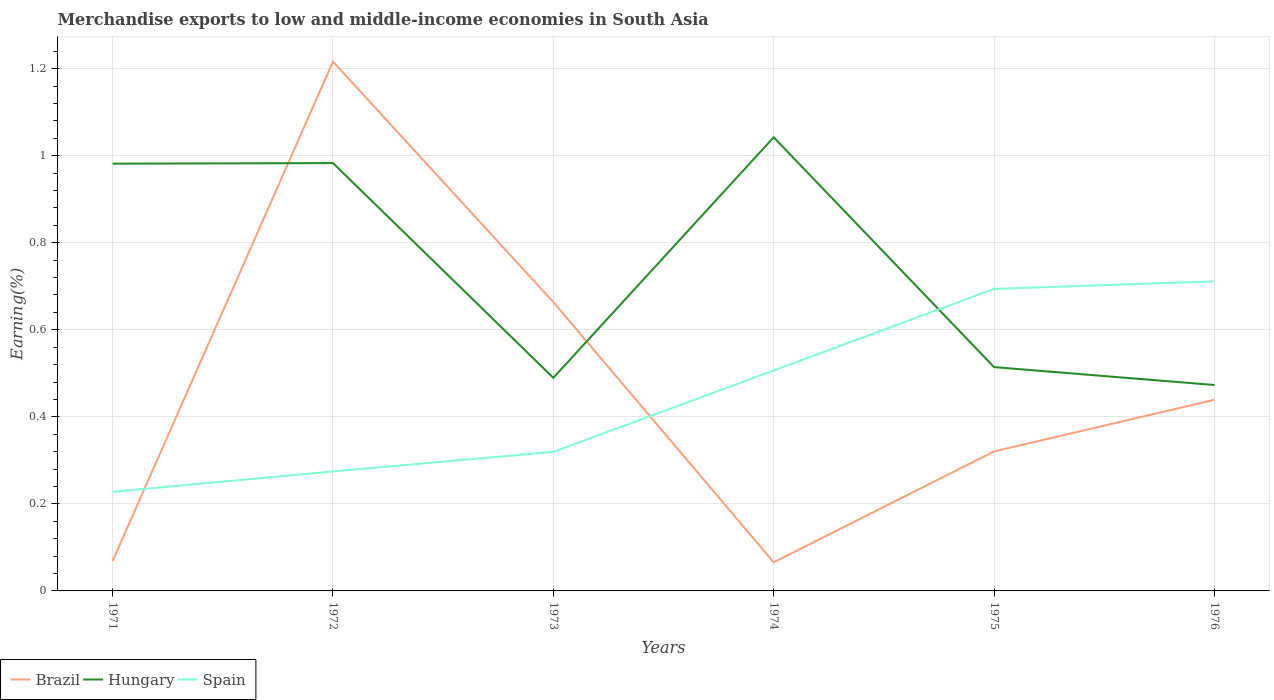Is the number of lines equal to the number of legend labels?
Give a very brief answer. Yes. Across all years, what is the maximum percentage of amount earned from merchandise exports in Brazil?
Provide a short and direct response. 0.07. What is the total percentage of amount earned from merchandise exports in Spain in the graph?
Keep it short and to the point. -0.19. What is the difference between the highest and the second highest percentage of amount earned from merchandise exports in Brazil?
Provide a succinct answer. 1.15. What is the difference between the highest and the lowest percentage of amount earned from merchandise exports in Spain?
Offer a terse response. 3. How many lines are there?
Give a very brief answer. 3. Does the graph contain grids?
Provide a succinct answer. Yes. How are the legend labels stacked?
Give a very brief answer. Horizontal. What is the title of the graph?
Provide a succinct answer. Merchandise exports to low and middle-income economies in South Asia. What is the label or title of the Y-axis?
Offer a terse response. Earning(%). What is the Earning(%) in Brazil in 1971?
Provide a succinct answer. 0.07. What is the Earning(%) in Hungary in 1971?
Give a very brief answer. 0.98. What is the Earning(%) of Spain in 1971?
Offer a terse response. 0.23. What is the Earning(%) of Brazil in 1972?
Offer a very short reply. 1.22. What is the Earning(%) of Hungary in 1972?
Make the answer very short. 0.98. What is the Earning(%) of Spain in 1972?
Make the answer very short. 0.27. What is the Earning(%) of Brazil in 1973?
Your response must be concise. 0.66. What is the Earning(%) of Hungary in 1973?
Your answer should be very brief. 0.49. What is the Earning(%) in Spain in 1973?
Offer a very short reply. 0.32. What is the Earning(%) in Brazil in 1974?
Provide a short and direct response. 0.07. What is the Earning(%) of Hungary in 1974?
Your answer should be compact. 1.04. What is the Earning(%) in Spain in 1974?
Provide a succinct answer. 0.51. What is the Earning(%) in Brazil in 1975?
Offer a very short reply. 0.32. What is the Earning(%) of Hungary in 1975?
Give a very brief answer. 0.51. What is the Earning(%) of Spain in 1975?
Give a very brief answer. 0.69. What is the Earning(%) in Brazil in 1976?
Your answer should be very brief. 0.44. What is the Earning(%) in Hungary in 1976?
Your answer should be compact. 0.47. What is the Earning(%) in Spain in 1976?
Offer a very short reply. 0.71. Across all years, what is the maximum Earning(%) in Brazil?
Make the answer very short. 1.22. Across all years, what is the maximum Earning(%) of Hungary?
Give a very brief answer. 1.04. Across all years, what is the maximum Earning(%) of Spain?
Your response must be concise. 0.71. Across all years, what is the minimum Earning(%) in Brazil?
Your answer should be compact. 0.07. Across all years, what is the minimum Earning(%) of Hungary?
Provide a short and direct response. 0.47. Across all years, what is the minimum Earning(%) in Spain?
Ensure brevity in your answer.  0.23. What is the total Earning(%) in Brazil in the graph?
Make the answer very short. 2.77. What is the total Earning(%) of Hungary in the graph?
Provide a succinct answer. 4.48. What is the total Earning(%) of Spain in the graph?
Offer a very short reply. 2.73. What is the difference between the Earning(%) in Brazil in 1971 and that in 1972?
Provide a short and direct response. -1.15. What is the difference between the Earning(%) in Hungary in 1971 and that in 1972?
Offer a terse response. -0. What is the difference between the Earning(%) of Spain in 1971 and that in 1972?
Your response must be concise. -0.05. What is the difference between the Earning(%) in Brazil in 1971 and that in 1973?
Your response must be concise. -0.59. What is the difference between the Earning(%) of Hungary in 1971 and that in 1973?
Your response must be concise. 0.49. What is the difference between the Earning(%) in Spain in 1971 and that in 1973?
Keep it short and to the point. -0.09. What is the difference between the Earning(%) in Brazil in 1971 and that in 1974?
Ensure brevity in your answer.  0. What is the difference between the Earning(%) of Hungary in 1971 and that in 1974?
Provide a short and direct response. -0.06. What is the difference between the Earning(%) in Spain in 1971 and that in 1974?
Offer a terse response. -0.28. What is the difference between the Earning(%) of Brazil in 1971 and that in 1975?
Your answer should be compact. -0.25. What is the difference between the Earning(%) in Hungary in 1971 and that in 1975?
Make the answer very short. 0.47. What is the difference between the Earning(%) of Spain in 1971 and that in 1975?
Offer a terse response. -0.47. What is the difference between the Earning(%) of Brazil in 1971 and that in 1976?
Your response must be concise. -0.37. What is the difference between the Earning(%) in Hungary in 1971 and that in 1976?
Make the answer very short. 0.51. What is the difference between the Earning(%) of Spain in 1971 and that in 1976?
Offer a very short reply. -0.48. What is the difference between the Earning(%) in Brazil in 1972 and that in 1973?
Provide a succinct answer. 0.55. What is the difference between the Earning(%) of Hungary in 1972 and that in 1973?
Give a very brief answer. 0.49. What is the difference between the Earning(%) of Spain in 1972 and that in 1973?
Your answer should be very brief. -0.04. What is the difference between the Earning(%) in Brazil in 1972 and that in 1974?
Provide a succinct answer. 1.15. What is the difference between the Earning(%) in Hungary in 1972 and that in 1974?
Offer a terse response. -0.06. What is the difference between the Earning(%) in Spain in 1972 and that in 1974?
Offer a terse response. -0.23. What is the difference between the Earning(%) of Brazil in 1972 and that in 1975?
Offer a terse response. 0.9. What is the difference between the Earning(%) in Hungary in 1972 and that in 1975?
Make the answer very short. 0.47. What is the difference between the Earning(%) in Spain in 1972 and that in 1975?
Provide a succinct answer. -0.42. What is the difference between the Earning(%) of Brazil in 1972 and that in 1976?
Offer a very short reply. 0.78. What is the difference between the Earning(%) of Hungary in 1972 and that in 1976?
Your response must be concise. 0.51. What is the difference between the Earning(%) of Spain in 1972 and that in 1976?
Offer a very short reply. -0.44. What is the difference between the Earning(%) of Brazil in 1973 and that in 1974?
Offer a terse response. 0.6. What is the difference between the Earning(%) of Hungary in 1973 and that in 1974?
Ensure brevity in your answer.  -0.55. What is the difference between the Earning(%) of Spain in 1973 and that in 1974?
Offer a terse response. -0.19. What is the difference between the Earning(%) in Brazil in 1973 and that in 1975?
Your answer should be very brief. 0.34. What is the difference between the Earning(%) in Hungary in 1973 and that in 1975?
Provide a succinct answer. -0.02. What is the difference between the Earning(%) of Spain in 1973 and that in 1975?
Keep it short and to the point. -0.37. What is the difference between the Earning(%) of Brazil in 1973 and that in 1976?
Your answer should be compact. 0.22. What is the difference between the Earning(%) of Hungary in 1973 and that in 1976?
Ensure brevity in your answer.  0.02. What is the difference between the Earning(%) of Spain in 1973 and that in 1976?
Your answer should be compact. -0.39. What is the difference between the Earning(%) in Brazil in 1974 and that in 1975?
Your answer should be compact. -0.25. What is the difference between the Earning(%) of Hungary in 1974 and that in 1975?
Keep it short and to the point. 0.53. What is the difference between the Earning(%) in Spain in 1974 and that in 1975?
Your response must be concise. -0.19. What is the difference between the Earning(%) in Brazil in 1974 and that in 1976?
Provide a succinct answer. -0.37. What is the difference between the Earning(%) in Hungary in 1974 and that in 1976?
Keep it short and to the point. 0.57. What is the difference between the Earning(%) of Spain in 1974 and that in 1976?
Your answer should be compact. -0.2. What is the difference between the Earning(%) of Brazil in 1975 and that in 1976?
Your answer should be very brief. -0.12. What is the difference between the Earning(%) of Hungary in 1975 and that in 1976?
Offer a terse response. 0.04. What is the difference between the Earning(%) of Spain in 1975 and that in 1976?
Give a very brief answer. -0.02. What is the difference between the Earning(%) in Brazil in 1971 and the Earning(%) in Hungary in 1972?
Your answer should be compact. -0.91. What is the difference between the Earning(%) in Brazil in 1971 and the Earning(%) in Spain in 1972?
Give a very brief answer. -0.21. What is the difference between the Earning(%) in Hungary in 1971 and the Earning(%) in Spain in 1972?
Make the answer very short. 0.71. What is the difference between the Earning(%) of Brazil in 1971 and the Earning(%) of Hungary in 1973?
Give a very brief answer. -0.42. What is the difference between the Earning(%) of Brazil in 1971 and the Earning(%) of Spain in 1973?
Give a very brief answer. -0.25. What is the difference between the Earning(%) in Hungary in 1971 and the Earning(%) in Spain in 1973?
Provide a succinct answer. 0.66. What is the difference between the Earning(%) in Brazil in 1971 and the Earning(%) in Hungary in 1974?
Offer a terse response. -0.97. What is the difference between the Earning(%) in Brazil in 1971 and the Earning(%) in Spain in 1974?
Your answer should be compact. -0.44. What is the difference between the Earning(%) in Hungary in 1971 and the Earning(%) in Spain in 1974?
Provide a short and direct response. 0.48. What is the difference between the Earning(%) of Brazil in 1971 and the Earning(%) of Hungary in 1975?
Keep it short and to the point. -0.45. What is the difference between the Earning(%) in Brazil in 1971 and the Earning(%) in Spain in 1975?
Make the answer very short. -0.63. What is the difference between the Earning(%) in Hungary in 1971 and the Earning(%) in Spain in 1975?
Your answer should be compact. 0.29. What is the difference between the Earning(%) of Brazil in 1971 and the Earning(%) of Hungary in 1976?
Ensure brevity in your answer.  -0.4. What is the difference between the Earning(%) in Brazil in 1971 and the Earning(%) in Spain in 1976?
Give a very brief answer. -0.64. What is the difference between the Earning(%) in Hungary in 1971 and the Earning(%) in Spain in 1976?
Ensure brevity in your answer.  0.27. What is the difference between the Earning(%) of Brazil in 1972 and the Earning(%) of Hungary in 1973?
Offer a terse response. 0.73. What is the difference between the Earning(%) of Brazil in 1972 and the Earning(%) of Spain in 1973?
Provide a succinct answer. 0.9. What is the difference between the Earning(%) of Hungary in 1972 and the Earning(%) of Spain in 1973?
Offer a very short reply. 0.66. What is the difference between the Earning(%) in Brazil in 1972 and the Earning(%) in Hungary in 1974?
Your answer should be very brief. 0.17. What is the difference between the Earning(%) in Brazil in 1972 and the Earning(%) in Spain in 1974?
Keep it short and to the point. 0.71. What is the difference between the Earning(%) in Hungary in 1972 and the Earning(%) in Spain in 1974?
Give a very brief answer. 0.48. What is the difference between the Earning(%) in Brazil in 1972 and the Earning(%) in Hungary in 1975?
Your response must be concise. 0.7. What is the difference between the Earning(%) in Brazil in 1972 and the Earning(%) in Spain in 1975?
Your answer should be very brief. 0.52. What is the difference between the Earning(%) in Hungary in 1972 and the Earning(%) in Spain in 1975?
Offer a very short reply. 0.29. What is the difference between the Earning(%) of Brazil in 1972 and the Earning(%) of Hungary in 1976?
Provide a short and direct response. 0.74. What is the difference between the Earning(%) in Brazil in 1972 and the Earning(%) in Spain in 1976?
Offer a very short reply. 0.51. What is the difference between the Earning(%) of Hungary in 1972 and the Earning(%) of Spain in 1976?
Ensure brevity in your answer.  0.27. What is the difference between the Earning(%) in Brazil in 1973 and the Earning(%) in Hungary in 1974?
Give a very brief answer. -0.38. What is the difference between the Earning(%) of Brazil in 1973 and the Earning(%) of Spain in 1974?
Your answer should be very brief. 0.16. What is the difference between the Earning(%) of Hungary in 1973 and the Earning(%) of Spain in 1974?
Your response must be concise. -0.02. What is the difference between the Earning(%) of Brazil in 1973 and the Earning(%) of Hungary in 1975?
Your response must be concise. 0.15. What is the difference between the Earning(%) of Brazil in 1973 and the Earning(%) of Spain in 1975?
Provide a succinct answer. -0.03. What is the difference between the Earning(%) of Hungary in 1973 and the Earning(%) of Spain in 1975?
Give a very brief answer. -0.2. What is the difference between the Earning(%) of Brazil in 1973 and the Earning(%) of Hungary in 1976?
Keep it short and to the point. 0.19. What is the difference between the Earning(%) in Brazil in 1973 and the Earning(%) in Spain in 1976?
Offer a terse response. -0.05. What is the difference between the Earning(%) in Hungary in 1973 and the Earning(%) in Spain in 1976?
Offer a terse response. -0.22. What is the difference between the Earning(%) in Brazil in 1974 and the Earning(%) in Hungary in 1975?
Make the answer very short. -0.45. What is the difference between the Earning(%) in Brazil in 1974 and the Earning(%) in Spain in 1975?
Your answer should be compact. -0.63. What is the difference between the Earning(%) in Hungary in 1974 and the Earning(%) in Spain in 1975?
Your answer should be compact. 0.35. What is the difference between the Earning(%) in Brazil in 1974 and the Earning(%) in Hungary in 1976?
Offer a terse response. -0.41. What is the difference between the Earning(%) in Brazil in 1974 and the Earning(%) in Spain in 1976?
Offer a terse response. -0.65. What is the difference between the Earning(%) in Hungary in 1974 and the Earning(%) in Spain in 1976?
Ensure brevity in your answer.  0.33. What is the difference between the Earning(%) in Brazil in 1975 and the Earning(%) in Hungary in 1976?
Ensure brevity in your answer.  -0.15. What is the difference between the Earning(%) of Brazil in 1975 and the Earning(%) of Spain in 1976?
Keep it short and to the point. -0.39. What is the difference between the Earning(%) in Hungary in 1975 and the Earning(%) in Spain in 1976?
Ensure brevity in your answer.  -0.2. What is the average Earning(%) of Brazil per year?
Give a very brief answer. 0.46. What is the average Earning(%) in Hungary per year?
Make the answer very short. 0.75. What is the average Earning(%) in Spain per year?
Offer a very short reply. 0.46. In the year 1971, what is the difference between the Earning(%) of Brazil and Earning(%) of Hungary?
Make the answer very short. -0.91. In the year 1971, what is the difference between the Earning(%) of Brazil and Earning(%) of Spain?
Ensure brevity in your answer.  -0.16. In the year 1971, what is the difference between the Earning(%) of Hungary and Earning(%) of Spain?
Your response must be concise. 0.75. In the year 1972, what is the difference between the Earning(%) of Brazil and Earning(%) of Hungary?
Offer a very short reply. 0.23. In the year 1972, what is the difference between the Earning(%) of Brazil and Earning(%) of Spain?
Keep it short and to the point. 0.94. In the year 1972, what is the difference between the Earning(%) in Hungary and Earning(%) in Spain?
Give a very brief answer. 0.71. In the year 1973, what is the difference between the Earning(%) in Brazil and Earning(%) in Hungary?
Ensure brevity in your answer.  0.17. In the year 1973, what is the difference between the Earning(%) in Brazil and Earning(%) in Spain?
Ensure brevity in your answer.  0.34. In the year 1973, what is the difference between the Earning(%) in Hungary and Earning(%) in Spain?
Your answer should be compact. 0.17. In the year 1974, what is the difference between the Earning(%) of Brazil and Earning(%) of Hungary?
Offer a terse response. -0.98. In the year 1974, what is the difference between the Earning(%) of Brazil and Earning(%) of Spain?
Provide a short and direct response. -0.44. In the year 1974, what is the difference between the Earning(%) of Hungary and Earning(%) of Spain?
Your answer should be compact. 0.54. In the year 1975, what is the difference between the Earning(%) of Brazil and Earning(%) of Hungary?
Make the answer very short. -0.19. In the year 1975, what is the difference between the Earning(%) of Brazil and Earning(%) of Spain?
Provide a succinct answer. -0.37. In the year 1975, what is the difference between the Earning(%) of Hungary and Earning(%) of Spain?
Your answer should be very brief. -0.18. In the year 1976, what is the difference between the Earning(%) in Brazil and Earning(%) in Hungary?
Offer a terse response. -0.03. In the year 1976, what is the difference between the Earning(%) of Brazil and Earning(%) of Spain?
Make the answer very short. -0.27. In the year 1976, what is the difference between the Earning(%) in Hungary and Earning(%) in Spain?
Offer a terse response. -0.24. What is the ratio of the Earning(%) of Brazil in 1971 to that in 1972?
Your response must be concise. 0.06. What is the ratio of the Earning(%) in Spain in 1971 to that in 1972?
Your answer should be compact. 0.83. What is the ratio of the Earning(%) of Brazil in 1971 to that in 1973?
Provide a succinct answer. 0.1. What is the ratio of the Earning(%) in Hungary in 1971 to that in 1973?
Your response must be concise. 2. What is the ratio of the Earning(%) in Spain in 1971 to that in 1973?
Provide a short and direct response. 0.71. What is the ratio of the Earning(%) in Brazil in 1971 to that in 1974?
Offer a very short reply. 1.05. What is the ratio of the Earning(%) of Hungary in 1971 to that in 1974?
Make the answer very short. 0.94. What is the ratio of the Earning(%) in Spain in 1971 to that in 1974?
Give a very brief answer. 0.45. What is the ratio of the Earning(%) of Brazil in 1971 to that in 1975?
Offer a very short reply. 0.21. What is the ratio of the Earning(%) in Hungary in 1971 to that in 1975?
Make the answer very short. 1.91. What is the ratio of the Earning(%) of Spain in 1971 to that in 1975?
Keep it short and to the point. 0.33. What is the ratio of the Earning(%) of Brazil in 1971 to that in 1976?
Keep it short and to the point. 0.16. What is the ratio of the Earning(%) of Hungary in 1971 to that in 1976?
Give a very brief answer. 2.07. What is the ratio of the Earning(%) in Spain in 1971 to that in 1976?
Offer a terse response. 0.32. What is the ratio of the Earning(%) of Brazil in 1972 to that in 1973?
Your answer should be very brief. 1.83. What is the ratio of the Earning(%) of Hungary in 1972 to that in 1973?
Ensure brevity in your answer.  2.01. What is the ratio of the Earning(%) in Spain in 1972 to that in 1973?
Your answer should be very brief. 0.86. What is the ratio of the Earning(%) of Brazil in 1972 to that in 1974?
Provide a succinct answer. 18.49. What is the ratio of the Earning(%) in Hungary in 1972 to that in 1974?
Provide a succinct answer. 0.94. What is the ratio of the Earning(%) in Spain in 1972 to that in 1974?
Ensure brevity in your answer.  0.54. What is the ratio of the Earning(%) of Brazil in 1972 to that in 1975?
Give a very brief answer. 3.79. What is the ratio of the Earning(%) of Hungary in 1972 to that in 1975?
Provide a short and direct response. 1.91. What is the ratio of the Earning(%) of Spain in 1972 to that in 1975?
Give a very brief answer. 0.4. What is the ratio of the Earning(%) in Brazil in 1972 to that in 1976?
Offer a terse response. 2.77. What is the ratio of the Earning(%) in Hungary in 1972 to that in 1976?
Give a very brief answer. 2.08. What is the ratio of the Earning(%) in Spain in 1972 to that in 1976?
Give a very brief answer. 0.39. What is the ratio of the Earning(%) in Brazil in 1973 to that in 1974?
Make the answer very short. 10.09. What is the ratio of the Earning(%) in Hungary in 1973 to that in 1974?
Provide a succinct answer. 0.47. What is the ratio of the Earning(%) of Spain in 1973 to that in 1974?
Give a very brief answer. 0.63. What is the ratio of the Earning(%) of Brazil in 1973 to that in 1975?
Offer a terse response. 2.07. What is the ratio of the Earning(%) of Hungary in 1973 to that in 1975?
Provide a short and direct response. 0.95. What is the ratio of the Earning(%) of Spain in 1973 to that in 1975?
Offer a terse response. 0.46. What is the ratio of the Earning(%) in Brazil in 1973 to that in 1976?
Your response must be concise. 1.51. What is the ratio of the Earning(%) of Hungary in 1973 to that in 1976?
Provide a short and direct response. 1.03. What is the ratio of the Earning(%) in Spain in 1973 to that in 1976?
Offer a terse response. 0.45. What is the ratio of the Earning(%) in Brazil in 1974 to that in 1975?
Offer a very short reply. 0.21. What is the ratio of the Earning(%) of Hungary in 1974 to that in 1975?
Provide a succinct answer. 2.03. What is the ratio of the Earning(%) of Spain in 1974 to that in 1975?
Offer a very short reply. 0.73. What is the ratio of the Earning(%) in Brazil in 1974 to that in 1976?
Your response must be concise. 0.15. What is the ratio of the Earning(%) in Hungary in 1974 to that in 1976?
Give a very brief answer. 2.2. What is the ratio of the Earning(%) of Spain in 1974 to that in 1976?
Ensure brevity in your answer.  0.71. What is the ratio of the Earning(%) in Brazil in 1975 to that in 1976?
Give a very brief answer. 0.73. What is the ratio of the Earning(%) of Hungary in 1975 to that in 1976?
Your response must be concise. 1.09. What is the ratio of the Earning(%) in Spain in 1975 to that in 1976?
Your answer should be very brief. 0.98. What is the difference between the highest and the second highest Earning(%) in Brazil?
Offer a very short reply. 0.55. What is the difference between the highest and the second highest Earning(%) in Hungary?
Provide a succinct answer. 0.06. What is the difference between the highest and the second highest Earning(%) in Spain?
Keep it short and to the point. 0.02. What is the difference between the highest and the lowest Earning(%) in Brazil?
Give a very brief answer. 1.15. What is the difference between the highest and the lowest Earning(%) of Hungary?
Your answer should be compact. 0.57. What is the difference between the highest and the lowest Earning(%) in Spain?
Your answer should be compact. 0.48. 